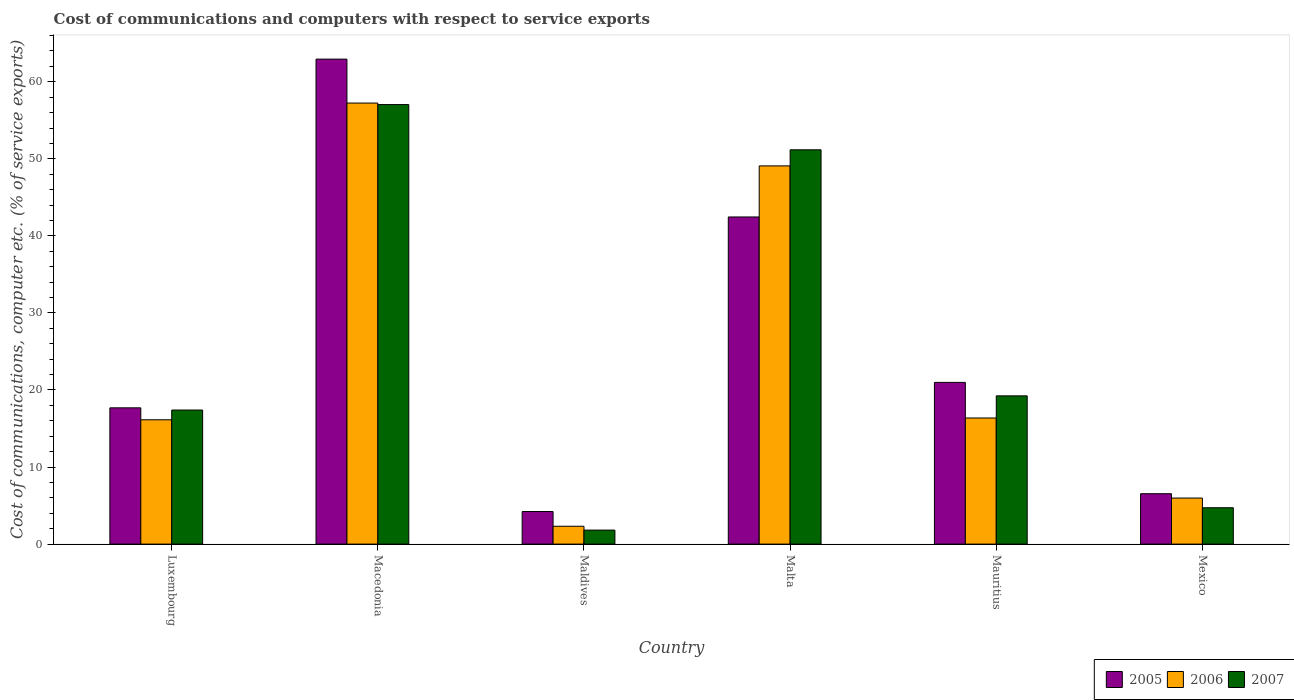What is the label of the 3rd group of bars from the left?
Keep it short and to the point. Maldives. In how many cases, is the number of bars for a given country not equal to the number of legend labels?
Your response must be concise. 0. What is the cost of communications and computers in 2005 in Mexico?
Offer a terse response. 6.54. Across all countries, what is the maximum cost of communications and computers in 2006?
Offer a very short reply. 57.24. Across all countries, what is the minimum cost of communications and computers in 2007?
Your answer should be very brief. 1.82. In which country was the cost of communications and computers in 2006 maximum?
Give a very brief answer. Macedonia. In which country was the cost of communications and computers in 2006 minimum?
Ensure brevity in your answer.  Maldives. What is the total cost of communications and computers in 2005 in the graph?
Provide a succinct answer. 154.83. What is the difference between the cost of communications and computers in 2006 in Macedonia and that in Maldives?
Your answer should be very brief. 54.92. What is the difference between the cost of communications and computers in 2005 in Mauritius and the cost of communications and computers in 2006 in Malta?
Keep it short and to the point. -28.1. What is the average cost of communications and computers in 2007 per country?
Provide a short and direct response. 25.23. What is the difference between the cost of communications and computers of/in 2007 and cost of communications and computers of/in 2006 in Maldives?
Your answer should be very brief. -0.5. In how many countries, is the cost of communications and computers in 2006 greater than 28 %?
Your answer should be very brief. 2. What is the ratio of the cost of communications and computers in 2005 in Luxembourg to that in Malta?
Offer a very short reply. 0.42. Is the cost of communications and computers in 2007 in Macedonia less than that in Maldives?
Your response must be concise. No. What is the difference between the highest and the second highest cost of communications and computers in 2006?
Your answer should be compact. -40.87. What is the difference between the highest and the lowest cost of communications and computers in 2007?
Give a very brief answer. 55.22. Is the sum of the cost of communications and computers in 2007 in Luxembourg and Macedonia greater than the maximum cost of communications and computers in 2006 across all countries?
Provide a succinct answer. Yes. What does the 1st bar from the right in Mexico represents?
Offer a terse response. 2007. How many bars are there?
Provide a short and direct response. 18. What is the difference between two consecutive major ticks on the Y-axis?
Provide a short and direct response. 10. Does the graph contain any zero values?
Offer a very short reply. No. What is the title of the graph?
Your answer should be compact. Cost of communications and computers with respect to service exports. Does "2008" appear as one of the legend labels in the graph?
Ensure brevity in your answer.  No. What is the label or title of the X-axis?
Provide a succinct answer. Country. What is the label or title of the Y-axis?
Your answer should be very brief. Cost of communications, computer etc. (% of service exports). What is the Cost of communications, computer etc. (% of service exports) in 2005 in Luxembourg?
Ensure brevity in your answer.  17.68. What is the Cost of communications, computer etc. (% of service exports) in 2006 in Luxembourg?
Make the answer very short. 16.13. What is the Cost of communications, computer etc. (% of service exports) in 2007 in Luxembourg?
Provide a succinct answer. 17.4. What is the Cost of communications, computer etc. (% of service exports) of 2005 in Macedonia?
Make the answer very short. 62.94. What is the Cost of communications, computer etc. (% of service exports) in 2006 in Macedonia?
Give a very brief answer. 57.24. What is the Cost of communications, computer etc. (% of service exports) in 2007 in Macedonia?
Make the answer very short. 57.04. What is the Cost of communications, computer etc. (% of service exports) of 2005 in Maldives?
Offer a terse response. 4.23. What is the Cost of communications, computer etc. (% of service exports) of 2006 in Maldives?
Provide a succinct answer. 2.32. What is the Cost of communications, computer etc. (% of service exports) in 2007 in Maldives?
Provide a succinct answer. 1.82. What is the Cost of communications, computer etc. (% of service exports) in 2005 in Malta?
Provide a short and direct response. 42.46. What is the Cost of communications, computer etc. (% of service exports) in 2006 in Malta?
Your answer should be compact. 49.08. What is the Cost of communications, computer etc. (% of service exports) in 2007 in Malta?
Provide a short and direct response. 51.17. What is the Cost of communications, computer etc. (% of service exports) in 2005 in Mauritius?
Keep it short and to the point. 20.99. What is the Cost of communications, computer etc. (% of service exports) in 2006 in Mauritius?
Offer a terse response. 16.37. What is the Cost of communications, computer etc. (% of service exports) in 2007 in Mauritius?
Offer a terse response. 19.24. What is the Cost of communications, computer etc. (% of service exports) in 2005 in Mexico?
Your answer should be very brief. 6.54. What is the Cost of communications, computer etc. (% of service exports) of 2006 in Mexico?
Provide a succinct answer. 5.98. What is the Cost of communications, computer etc. (% of service exports) of 2007 in Mexico?
Keep it short and to the point. 4.72. Across all countries, what is the maximum Cost of communications, computer etc. (% of service exports) of 2005?
Offer a terse response. 62.94. Across all countries, what is the maximum Cost of communications, computer etc. (% of service exports) of 2006?
Your response must be concise. 57.24. Across all countries, what is the maximum Cost of communications, computer etc. (% of service exports) of 2007?
Provide a short and direct response. 57.04. Across all countries, what is the minimum Cost of communications, computer etc. (% of service exports) of 2005?
Provide a succinct answer. 4.23. Across all countries, what is the minimum Cost of communications, computer etc. (% of service exports) in 2006?
Keep it short and to the point. 2.32. Across all countries, what is the minimum Cost of communications, computer etc. (% of service exports) in 2007?
Make the answer very short. 1.82. What is the total Cost of communications, computer etc. (% of service exports) in 2005 in the graph?
Give a very brief answer. 154.83. What is the total Cost of communications, computer etc. (% of service exports) in 2006 in the graph?
Give a very brief answer. 147.11. What is the total Cost of communications, computer etc. (% of service exports) in 2007 in the graph?
Your response must be concise. 151.38. What is the difference between the Cost of communications, computer etc. (% of service exports) of 2005 in Luxembourg and that in Macedonia?
Ensure brevity in your answer.  -45.25. What is the difference between the Cost of communications, computer etc. (% of service exports) in 2006 in Luxembourg and that in Macedonia?
Your answer should be very brief. -41.1. What is the difference between the Cost of communications, computer etc. (% of service exports) of 2007 in Luxembourg and that in Macedonia?
Your answer should be compact. -39.64. What is the difference between the Cost of communications, computer etc. (% of service exports) of 2005 in Luxembourg and that in Maldives?
Make the answer very short. 13.46. What is the difference between the Cost of communications, computer etc. (% of service exports) in 2006 in Luxembourg and that in Maldives?
Your answer should be very brief. 13.82. What is the difference between the Cost of communications, computer etc. (% of service exports) in 2007 in Luxembourg and that in Maldives?
Your answer should be very brief. 15.58. What is the difference between the Cost of communications, computer etc. (% of service exports) of 2005 in Luxembourg and that in Malta?
Provide a succinct answer. -24.77. What is the difference between the Cost of communications, computer etc. (% of service exports) of 2006 in Luxembourg and that in Malta?
Offer a very short reply. -32.95. What is the difference between the Cost of communications, computer etc. (% of service exports) of 2007 in Luxembourg and that in Malta?
Offer a terse response. -33.77. What is the difference between the Cost of communications, computer etc. (% of service exports) of 2005 in Luxembourg and that in Mauritius?
Provide a succinct answer. -3.3. What is the difference between the Cost of communications, computer etc. (% of service exports) of 2006 in Luxembourg and that in Mauritius?
Provide a short and direct response. -0.23. What is the difference between the Cost of communications, computer etc. (% of service exports) of 2007 in Luxembourg and that in Mauritius?
Make the answer very short. -1.84. What is the difference between the Cost of communications, computer etc. (% of service exports) in 2005 in Luxembourg and that in Mexico?
Ensure brevity in your answer.  11.14. What is the difference between the Cost of communications, computer etc. (% of service exports) of 2006 in Luxembourg and that in Mexico?
Offer a very short reply. 10.16. What is the difference between the Cost of communications, computer etc. (% of service exports) in 2007 in Luxembourg and that in Mexico?
Make the answer very short. 12.68. What is the difference between the Cost of communications, computer etc. (% of service exports) of 2005 in Macedonia and that in Maldives?
Provide a short and direct response. 58.71. What is the difference between the Cost of communications, computer etc. (% of service exports) of 2006 in Macedonia and that in Maldives?
Your answer should be compact. 54.92. What is the difference between the Cost of communications, computer etc. (% of service exports) in 2007 in Macedonia and that in Maldives?
Your answer should be very brief. 55.22. What is the difference between the Cost of communications, computer etc. (% of service exports) in 2005 in Macedonia and that in Malta?
Give a very brief answer. 20.48. What is the difference between the Cost of communications, computer etc. (% of service exports) of 2006 in Macedonia and that in Malta?
Provide a short and direct response. 8.15. What is the difference between the Cost of communications, computer etc. (% of service exports) of 2007 in Macedonia and that in Malta?
Your answer should be compact. 5.87. What is the difference between the Cost of communications, computer etc. (% of service exports) of 2005 in Macedonia and that in Mauritius?
Make the answer very short. 41.95. What is the difference between the Cost of communications, computer etc. (% of service exports) in 2006 in Macedonia and that in Mauritius?
Your answer should be compact. 40.87. What is the difference between the Cost of communications, computer etc. (% of service exports) in 2007 in Macedonia and that in Mauritius?
Keep it short and to the point. 37.8. What is the difference between the Cost of communications, computer etc. (% of service exports) in 2005 in Macedonia and that in Mexico?
Your answer should be very brief. 56.4. What is the difference between the Cost of communications, computer etc. (% of service exports) in 2006 in Macedonia and that in Mexico?
Your answer should be compact. 51.26. What is the difference between the Cost of communications, computer etc. (% of service exports) of 2007 in Macedonia and that in Mexico?
Ensure brevity in your answer.  52.32. What is the difference between the Cost of communications, computer etc. (% of service exports) in 2005 in Maldives and that in Malta?
Keep it short and to the point. -38.23. What is the difference between the Cost of communications, computer etc. (% of service exports) of 2006 in Maldives and that in Malta?
Give a very brief answer. -46.77. What is the difference between the Cost of communications, computer etc. (% of service exports) of 2007 in Maldives and that in Malta?
Keep it short and to the point. -49.35. What is the difference between the Cost of communications, computer etc. (% of service exports) in 2005 in Maldives and that in Mauritius?
Your answer should be compact. -16.76. What is the difference between the Cost of communications, computer etc. (% of service exports) in 2006 in Maldives and that in Mauritius?
Your answer should be very brief. -14.05. What is the difference between the Cost of communications, computer etc. (% of service exports) of 2007 in Maldives and that in Mauritius?
Provide a short and direct response. -17.42. What is the difference between the Cost of communications, computer etc. (% of service exports) in 2005 in Maldives and that in Mexico?
Your response must be concise. -2.31. What is the difference between the Cost of communications, computer etc. (% of service exports) in 2006 in Maldives and that in Mexico?
Provide a succinct answer. -3.66. What is the difference between the Cost of communications, computer etc. (% of service exports) in 2007 in Maldives and that in Mexico?
Keep it short and to the point. -2.9. What is the difference between the Cost of communications, computer etc. (% of service exports) in 2005 in Malta and that in Mauritius?
Your answer should be compact. 21.47. What is the difference between the Cost of communications, computer etc. (% of service exports) in 2006 in Malta and that in Mauritius?
Your answer should be compact. 32.72. What is the difference between the Cost of communications, computer etc. (% of service exports) of 2007 in Malta and that in Mauritius?
Ensure brevity in your answer.  31.93. What is the difference between the Cost of communications, computer etc. (% of service exports) of 2005 in Malta and that in Mexico?
Your response must be concise. 35.92. What is the difference between the Cost of communications, computer etc. (% of service exports) of 2006 in Malta and that in Mexico?
Provide a succinct answer. 43.11. What is the difference between the Cost of communications, computer etc. (% of service exports) of 2007 in Malta and that in Mexico?
Your answer should be very brief. 46.45. What is the difference between the Cost of communications, computer etc. (% of service exports) of 2005 in Mauritius and that in Mexico?
Ensure brevity in your answer.  14.45. What is the difference between the Cost of communications, computer etc. (% of service exports) in 2006 in Mauritius and that in Mexico?
Provide a short and direct response. 10.39. What is the difference between the Cost of communications, computer etc. (% of service exports) of 2007 in Mauritius and that in Mexico?
Your answer should be compact. 14.52. What is the difference between the Cost of communications, computer etc. (% of service exports) of 2005 in Luxembourg and the Cost of communications, computer etc. (% of service exports) of 2006 in Macedonia?
Your answer should be compact. -39.55. What is the difference between the Cost of communications, computer etc. (% of service exports) of 2005 in Luxembourg and the Cost of communications, computer etc. (% of service exports) of 2007 in Macedonia?
Your answer should be compact. -39.35. What is the difference between the Cost of communications, computer etc. (% of service exports) in 2006 in Luxembourg and the Cost of communications, computer etc. (% of service exports) in 2007 in Macedonia?
Keep it short and to the point. -40.91. What is the difference between the Cost of communications, computer etc. (% of service exports) in 2005 in Luxembourg and the Cost of communications, computer etc. (% of service exports) in 2006 in Maldives?
Offer a terse response. 15.37. What is the difference between the Cost of communications, computer etc. (% of service exports) in 2005 in Luxembourg and the Cost of communications, computer etc. (% of service exports) in 2007 in Maldives?
Provide a succinct answer. 15.87. What is the difference between the Cost of communications, computer etc. (% of service exports) in 2006 in Luxembourg and the Cost of communications, computer etc. (% of service exports) in 2007 in Maldives?
Ensure brevity in your answer.  14.32. What is the difference between the Cost of communications, computer etc. (% of service exports) in 2005 in Luxembourg and the Cost of communications, computer etc. (% of service exports) in 2006 in Malta?
Your response must be concise. -31.4. What is the difference between the Cost of communications, computer etc. (% of service exports) in 2005 in Luxembourg and the Cost of communications, computer etc. (% of service exports) in 2007 in Malta?
Your response must be concise. -33.49. What is the difference between the Cost of communications, computer etc. (% of service exports) in 2006 in Luxembourg and the Cost of communications, computer etc. (% of service exports) in 2007 in Malta?
Keep it short and to the point. -35.04. What is the difference between the Cost of communications, computer etc. (% of service exports) of 2005 in Luxembourg and the Cost of communications, computer etc. (% of service exports) of 2006 in Mauritius?
Your response must be concise. 1.32. What is the difference between the Cost of communications, computer etc. (% of service exports) in 2005 in Luxembourg and the Cost of communications, computer etc. (% of service exports) in 2007 in Mauritius?
Offer a very short reply. -1.55. What is the difference between the Cost of communications, computer etc. (% of service exports) in 2006 in Luxembourg and the Cost of communications, computer etc. (% of service exports) in 2007 in Mauritius?
Provide a short and direct response. -3.1. What is the difference between the Cost of communications, computer etc. (% of service exports) in 2005 in Luxembourg and the Cost of communications, computer etc. (% of service exports) in 2006 in Mexico?
Provide a succinct answer. 11.71. What is the difference between the Cost of communications, computer etc. (% of service exports) in 2005 in Luxembourg and the Cost of communications, computer etc. (% of service exports) in 2007 in Mexico?
Your answer should be compact. 12.96. What is the difference between the Cost of communications, computer etc. (% of service exports) of 2006 in Luxembourg and the Cost of communications, computer etc. (% of service exports) of 2007 in Mexico?
Ensure brevity in your answer.  11.41. What is the difference between the Cost of communications, computer etc. (% of service exports) in 2005 in Macedonia and the Cost of communications, computer etc. (% of service exports) in 2006 in Maldives?
Give a very brief answer. 60.62. What is the difference between the Cost of communications, computer etc. (% of service exports) in 2005 in Macedonia and the Cost of communications, computer etc. (% of service exports) in 2007 in Maldives?
Your answer should be very brief. 61.12. What is the difference between the Cost of communications, computer etc. (% of service exports) of 2006 in Macedonia and the Cost of communications, computer etc. (% of service exports) of 2007 in Maldives?
Your answer should be compact. 55.42. What is the difference between the Cost of communications, computer etc. (% of service exports) of 2005 in Macedonia and the Cost of communications, computer etc. (% of service exports) of 2006 in Malta?
Provide a succinct answer. 13.86. What is the difference between the Cost of communications, computer etc. (% of service exports) of 2005 in Macedonia and the Cost of communications, computer etc. (% of service exports) of 2007 in Malta?
Make the answer very short. 11.77. What is the difference between the Cost of communications, computer etc. (% of service exports) in 2006 in Macedonia and the Cost of communications, computer etc. (% of service exports) in 2007 in Malta?
Make the answer very short. 6.07. What is the difference between the Cost of communications, computer etc. (% of service exports) of 2005 in Macedonia and the Cost of communications, computer etc. (% of service exports) of 2006 in Mauritius?
Keep it short and to the point. 46.57. What is the difference between the Cost of communications, computer etc. (% of service exports) of 2005 in Macedonia and the Cost of communications, computer etc. (% of service exports) of 2007 in Mauritius?
Provide a short and direct response. 43.7. What is the difference between the Cost of communications, computer etc. (% of service exports) in 2006 in Macedonia and the Cost of communications, computer etc. (% of service exports) in 2007 in Mauritius?
Make the answer very short. 38. What is the difference between the Cost of communications, computer etc. (% of service exports) of 2005 in Macedonia and the Cost of communications, computer etc. (% of service exports) of 2006 in Mexico?
Your answer should be very brief. 56.96. What is the difference between the Cost of communications, computer etc. (% of service exports) in 2005 in Macedonia and the Cost of communications, computer etc. (% of service exports) in 2007 in Mexico?
Offer a terse response. 58.22. What is the difference between the Cost of communications, computer etc. (% of service exports) in 2006 in Macedonia and the Cost of communications, computer etc. (% of service exports) in 2007 in Mexico?
Ensure brevity in your answer.  52.52. What is the difference between the Cost of communications, computer etc. (% of service exports) of 2005 in Maldives and the Cost of communications, computer etc. (% of service exports) of 2006 in Malta?
Provide a short and direct response. -44.85. What is the difference between the Cost of communications, computer etc. (% of service exports) in 2005 in Maldives and the Cost of communications, computer etc. (% of service exports) in 2007 in Malta?
Provide a short and direct response. -46.94. What is the difference between the Cost of communications, computer etc. (% of service exports) in 2006 in Maldives and the Cost of communications, computer etc. (% of service exports) in 2007 in Malta?
Make the answer very short. -48.85. What is the difference between the Cost of communications, computer etc. (% of service exports) of 2005 in Maldives and the Cost of communications, computer etc. (% of service exports) of 2006 in Mauritius?
Your response must be concise. -12.14. What is the difference between the Cost of communications, computer etc. (% of service exports) of 2005 in Maldives and the Cost of communications, computer etc. (% of service exports) of 2007 in Mauritius?
Provide a short and direct response. -15.01. What is the difference between the Cost of communications, computer etc. (% of service exports) in 2006 in Maldives and the Cost of communications, computer etc. (% of service exports) in 2007 in Mauritius?
Offer a terse response. -16.92. What is the difference between the Cost of communications, computer etc. (% of service exports) in 2005 in Maldives and the Cost of communications, computer etc. (% of service exports) in 2006 in Mexico?
Offer a terse response. -1.75. What is the difference between the Cost of communications, computer etc. (% of service exports) in 2005 in Maldives and the Cost of communications, computer etc. (% of service exports) in 2007 in Mexico?
Make the answer very short. -0.49. What is the difference between the Cost of communications, computer etc. (% of service exports) of 2006 in Maldives and the Cost of communications, computer etc. (% of service exports) of 2007 in Mexico?
Give a very brief answer. -2.4. What is the difference between the Cost of communications, computer etc. (% of service exports) in 2005 in Malta and the Cost of communications, computer etc. (% of service exports) in 2006 in Mauritius?
Offer a terse response. 26.09. What is the difference between the Cost of communications, computer etc. (% of service exports) of 2005 in Malta and the Cost of communications, computer etc. (% of service exports) of 2007 in Mauritius?
Your response must be concise. 23.22. What is the difference between the Cost of communications, computer etc. (% of service exports) in 2006 in Malta and the Cost of communications, computer etc. (% of service exports) in 2007 in Mauritius?
Offer a very short reply. 29.84. What is the difference between the Cost of communications, computer etc. (% of service exports) of 2005 in Malta and the Cost of communications, computer etc. (% of service exports) of 2006 in Mexico?
Ensure brevity in your answer.  36.48. What is the difference between the Cost of communications, computer etc. (% of service exports) in 2005 in Malta and the Cost of communications, computer etc. (% of service exports) in 2007 in Mexico?
Make the answer very short. 37.74. What is the difference between the Cost of communications, computer etc. (% of service exports) in 2006 in Malta and the Cost of communications, computer etc. (% of service exports) in 2007 in Mexico?
Your response must be concise. 44.36. What is the difference between the Cost of communications, computer etc. (% of service exports) in 2005 in Mauritius and the Cost of communications, computer etc. (% of service exports) in 2006 in Mexico?
Provide a succinct answer. 15.01. What is the difference between the Cost of communications, computer etc. (% of service exports) of 2005 in Mauritius and the Cost of communications, computer etc. (% of service exports) of 2007 in Mexico?
Offer a terse response. 16.27. What is the difference between the Cost of communications, computer etc. (% of service exports) of 2006 in Mauritius and the Cost of communications, computer etc. (% of service exports) of 2007 in Mexico?
Your response must be concise. 11.65. What is the average Cost of communications, computer etc. (% of service exports) in 2005 per country?
Offer a terse response. 25.81. What is the average Cost of communications, computer etc. (% of service exports) in 2006 per country?
Ensure brevity in your answer.  24.52. What is the average Cost of communications, computer etc. (% of service exports) of 2007 per country?
Provide a succinct answer. 25.23. What is the difference between the Cost of communications, computer etc. (% of service exports) in 2005 and Cost of communications, computer etc. (% of service exports) in 2006 in Luxembourg?
Offer a terse response. 1.55. What is the difference between the Cost of communications, computer etc. (% of service exports) of 2005 and Cost of communications, computer etc. (% of service exports) of 2007 in Luxembourg?
Give a very brief answer. 0.29. What is the difference between the Cost of communications, computer etc. (% of service exports) in 2006 and Cost of communications, computer etc. (% of service exports) in 2007 in Luxembourg?
Keep it short and to the point. -1.26. What is the difference between the Cost of communications, computer etc. (% of service exports) in 2005 and Cost of communications, computer etc. (% of service exports) in 2006 in Macedonia?
Your response must be concise. 5.7. What is the difference between the Cost of communications, computer etc. (% of service exports) in 2005 and Cost of communications, computer etc. (% of service exports) in 2007 in Macedonia?
Keep it short and to the point. 5.9. What is the difference between the Cost of communications, computer etc. (% of service exports) in 2006 and Cost of communications, computer etc. (% of service exports) in 2007 in Macedonia?
Your answer should be compact. 0.2. What is the difference between the Cost of communications, computer etc. (% of service exports) of 2005 and Cost of communications, computer etc. (% of service exports) of 2006 in Maldives?
Provide a succinct answer. 1.91. What is the difference between the Cost of communications, computer etc. (% of service exports) in 2005 and Cost of communications, computer etc. (% of service exports) in 2007 in Maldives?
Your answer should be compact. 2.41. What is the difference between the Cost of communications, computer etc. (% of service exports) in 2006 and Cost of communications, computer etc. (% of service exports) in 2007 in Maldives?
Provide a succinct answer. 0.5. What is the difference between the Cost of communications, computer etc. (% of service exports) in 2005 and Cost of communications, computer etc. (% of service exports) in 2006 in Malta?
Offer a terse response. -6.63. What is the difference between the Cost of communications, computer etc. (% of service exports) of 2005 and Cost of communications, computer etc. (% of service exports) of 2007 in Malta?
Your response must be concise. -8.71. What is the difference between the Cost of communications, computer etc. (% of service exports) of 2006 and Cost of communications, computer etc. (% of service exports) of 2007 in Malta?
Ensure brevity in your answer.  -2.09. What is the difference between the Cost of communications, computer etc. (% of service exports) in 2005 and Cost of communications, computer etc. (% of service exports) in 2006 in Mauritius?
Keep it short and to the point. 4.62. What is the difference between the Cost of communications, computer etc. (% of service exports) in 2005 and Cost of communications, computer etc. (% of service exports) in 2007 in Mauritius?
Keep it short and to the point. 1.75. What is the difference between the Cost of communications, computer etc. (% of service exports) in 2006 and Cost of communications, computer etc. (% of service exports) in 2007 in Mauritius?
Provide a succinct answer. -2.87. What is the difference between the Cost of communications, computer etc. (% of service exports) in 2005 and Cost of communications, computer etc. (% of service exports) in 2006 in Mexico?
Your response must be concise. 0.56. What is the difference between the Cost of communications, computer etc. (% of service exports) in 2005 and Cost of communications, computer etc. (% of service exports) in 2007 in Mexico?
Offer a terse response. 1.82. What is the difference between the Cost of communications, computer etc. (% of service exports) in 2006 and Cost of communications, computer etc. (% of service exports) in 2007 in Mexico?
Give a very brief answer. 1.26. What is the ratio of the Cost of communications, computer etc. (% of service exports) in 2005 in Luxembourg to that in Macedonia?
Give a very brief answer. 0.28. What is the ratio of the Cost of communications, computer etc. (% of service exports) of 2006 in Luxembourg to that in Macedonia?
Ensure brevity in your answer.  0.28. What is the ratio of the Cost of communications, computer etc. (% of service exports) in 2007 in Luxembourg to that in Macedonia?
Provide a short and direct response. 0.3. What is the ratio of the Cost of communications, computer etc. (% of service exports) in 2005 in Luxembourg to that in Maldives?
Give a very brief answer. 4.18. What is the ratio of the Cost of communications, computer etc. (% of service exports) in 2006 in Luxembourg to that in Maldives?
Offer a terse response. 6.97. What is the ratio of the Cost of communications, computer etc. (% of service exports) in 2007 in Luxembourg to that in Maldives?
Your response must be concise. 9.57. What is the ratio of the Cost of communications, computer etc. (% of service exports) of 2005 in Luxembourg to that in Malta?
Your answer should be very brief. 0.42. What is the ratio of the Cost of communications, computer etc. (% of service exports) in 2006 in Luxembourg to that in Malta?
Your answer should be compact. 0.33. What is the ratio of the Cost of communications, computer etc. (% of service exports) of 2007 in Luxembourg to that in Malta?
Your answer should be very brief. 0.34. What is the ratio of the Cost of communications, computer etc. (% of service exports) in 2005 in Luxembourg to that in Mauritius?
Make the answer very short. 0.84. What is the ratio of the Cost of communications, computer etc. (% of service exports) of 2006 in Luxembourg to that in Mauritius?
Keep it short and to the point. 0.99. What is the ratio of the Cost of communications, computer etc. (% of service exports) in 2007 in Luxembourg to that in Mauritius?
Provide a short and direct response. 0.9. What is the ratio of the Cost of communications, computer etc. (% of service exports) of 2005 in Luxembourg to that in Mexico?
Your answer should be compact. 2.7. What is the ratio of the Cost of communications, computer etc. (% of service exports) in 2006 in Luxembourg to that in Mexico?
Provide a short and direct response. 2.7. What is the ratio of the Cost of communications, computer etc. (% of service exports) in 2007 in Luxembourg to that in Mexico?
Give a very brief answer. 3.69. What is the ratio of the Cost of communications, computer etc. (% of service exports) in 2005 in Macedonia to that in Maldives?
Offer a terse response. 14.89. What is the ratio of the Cost of communications, computer etc. (% of service exports) in 2006 in Macedonia to that in Maldives?
Your answer should be very brief. 24.72. What is the ratio of the Cost of communications, computer etc. (% of service exports) in 2007 in Macedonia to that in Maldives?
Your response must be concise. 31.38. What is the ratio of the Cost of communications, computer etc. (% of service exports) in 2005 in Macedonia to that in Malta?
Your answer should be compact. 1.48. What is the ratio of the Cost of communications, computer etc. (% of service exports) in 2006 in Macedonia to that in Malta?
Offer a very short reply. 1.17. What is the ratio of the Cost of communications, computer etc. (% of service exports) of 2007 in Macedonia to that in Malta?
Make the answer very short. 1.11. What is the ratio of the Cost of communications, computer etc. (% of service exports) of 2005 in Macedonia to that in Mauritius?
Ensure brevity in your answer.  3. What is the ratio of the Cost of communications, computer etc. (% of service exports) of 2006 in Macedonia to that in Mauritius?
Your answer should be compact. 3.5. What is the ratio of the Cost of communications, computer etc. (% of service exports) of 2007 in Macedonia to that in Mauritius?
Keep it short and to the point. 2.96. What is the ratio of the Cost of communications, computer etc. (% of service exports) of 2005 in Macedonia to that in Mexico?
Offer a terse response. 9.62. What is the ratio of the Cost of communications, computer etc. (% of service exports) in 2006 in Macedonia to that in Mexico?
Provide a short and direct response. 9.58. What is the ratio of the Cost of communications, computer etc. (% of service exports) in 2007 in Macedonia to that in Mexico?
Give a very brief answer. 12.09. What is the ratio of the Cost of communications, computer etc. (% of service exports) of 2005 in Maldives to that in Malta?
Offer a very short reply. 0.1. What is the ratio of the Cost of communications, computer etc. (% of service exports) of 2006 in Maldives to that in Malta?
Provide a short and direct response. 0.05. What is the ratio of the Cost of communications, computer etc. (% of service exports) of 2007 in Maldives to that in Malta?
Your response must be concise. 0.04. What is the ratio of the Cost of communications, computer etc. (% of service exports) in 2005 in Maldives to that in Mauritius?
Your response must be concise. 0.2. What is the ratio of the Cost of communications, computer etc. (% of service exports) of 2006 in Maldives to that in Mauritius?
Your response must be concise. 0.14. What is the ratio of the Cost of communications, computer etc. (% of service exports) of 2007 in Maldives to that in Mauritius?
Your response must be concise. 0.09. What is the ratio of the Cost of communications, computer etc. (% of service exports) in 2005 in Maldives to that in Mexico?
Give a very brief answer. 0.65. What is the ratio of the Cost of communications, computer etc. (% of service exports) of 2006 in Maldives to that in Mexico?
Make the answer very short. 0.39. What is the ratio of the Cost of communications, computer etc. (% of service exports) in 2007 in Maldives to that in Mexico?
Provide a short and direct response. 0.39. What is the ratio of the Cost of communications, computer etc. (% of service exports) of 2005 in Malta to that in Mauritius?
Your answer should be very brief. 2.02. What is the ratio of the Cost of communications, computer etc. (% of service exports) of 2006 in Malta to that in Mauritius?
Offer a terse response. 3. What is the ratio of the Cost of communications, computer etc. (% of service exports) of 2007 in Malta to that in Mauritius?
Your answer should be compact. 2.66. What is the ratio of the Cost of communications, computer etc. (% of service exports) of 2005 in Malta to that in Mexico?
Provide a succinct answer. 6.49. What is the ratio of the Cost of communications, computer etc. (% of service exports) in 2006 in Malta to that in Mexico?
Offer a terse response. 8.21. What is the ratio of the Cost of communications, computer etc. (% of service exports) in 2007 in Malta to that in Mexico?
Offer a very short reply. 10.84. What is the ratio of the Cost of communications, computer etc. (% of service exports) of 2005 in Mauritius to that in Mexico?
Give a very brief answer. 3.21. What is the ratio of the Cost of communications, computer etc. (% of service exports) of 2006 in Mauritius to that in Mexico?
Offer a very short reply. 2.74. What is the ratio of the Cost of communications, computer etc. (% of service exports) of 2007 in Mauritius to that in Mexico?
Provide a succinct answer. 4.08. What is the difference between the highest and the second highest Cost of communications, computer etc. (% of service exports) in 2005?
Offer a terse response. 20.48. What is the difference between the highest and the second highest Cost of communications, computer etc. (% of service exports) of 2006?
Provide a short and direct response. 8.15. What is the difference between the highest and the second highest Cost of communications, computer etc. (% of service exports) in 2007?
Make the answer very short. 5.87. What is the difference between the highest and the lowest Cost of communications, computer etc. (% of service exports) in 2005?
Offer a very short reply. 58.71. What is the difference between the highest and the lowest Cost of communications, computer etc. (% of service exports) in 2006?
Offer a terse response. 54.92. What is the difference between the highest and the lowest Cost of communications, computer etc. (% of service exports) in 2007?
Your response must be concise. 55.22. 